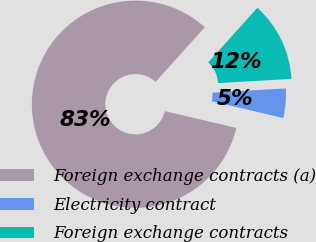<chart> <loc_0><loc_0><loc_500><loc_500><pie_chart><fcel>Foreign exchange contracts (a)<fcel>Electricity contract<fcel>Foreign exchange contracts<nl><fcel>83.0%<fcel>4.58%<fcel>12.42%<nl></chart> 